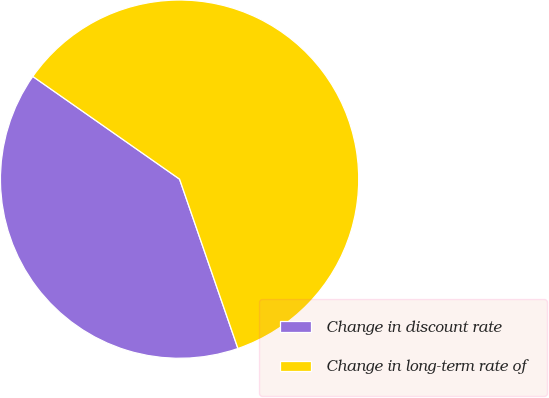Convert chart to OTSL. <chart><loc_0><loc_0><loc_500><loc_500><pie_chart><fcel>Change in discount rate<fcel>Change in long-term rate of<nl><fcel>40.0%<fcel>60.0%<nl></chart> 